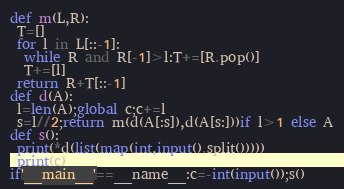<code> <loc_0><loc_0><loc_500><loc_500><_Python_>def m(L,R):
 T=[]
 for l in L[::-1]:
  while R and R[-1]>l:T+=[R.pop()]
  T+=[l]
 return R+T[::-1]
def d(A):
 l=len(A);global c;c+=l
 s=l//2;return m(d(A[:s]),d(A[s:]))if l>1 else A
def s():
 print(*d(list(map(int,input().split()))))
 print(c)
if'__main__'==__name__:c=-int(input());s()
</code> 